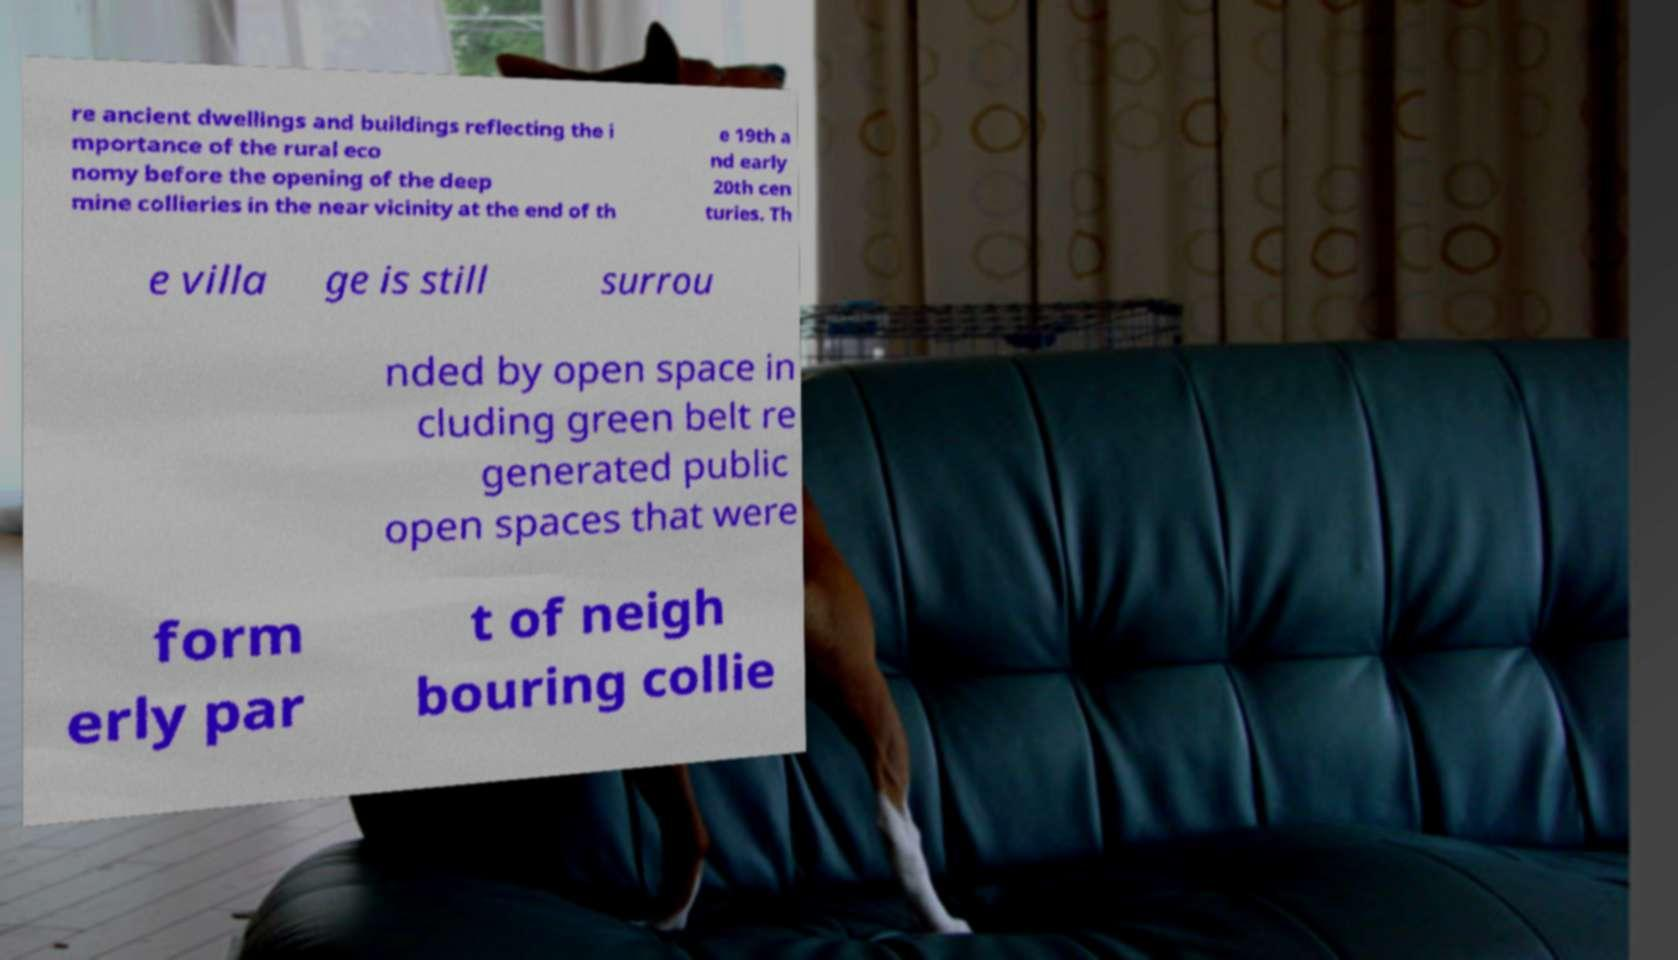Please read and relay the text visible in this image. What does it say? re ancient dwellings and buildings reflecting the i mportance of the rural eco nomy before the opening of the deep mine collieries in the near vicinity at the end of th e 19th a nd early 20th cen turies. Th e villa ge is still surrou nded by open space in cluding green belt re generated public open spaces that were form erly par t of neigh bouring collie 